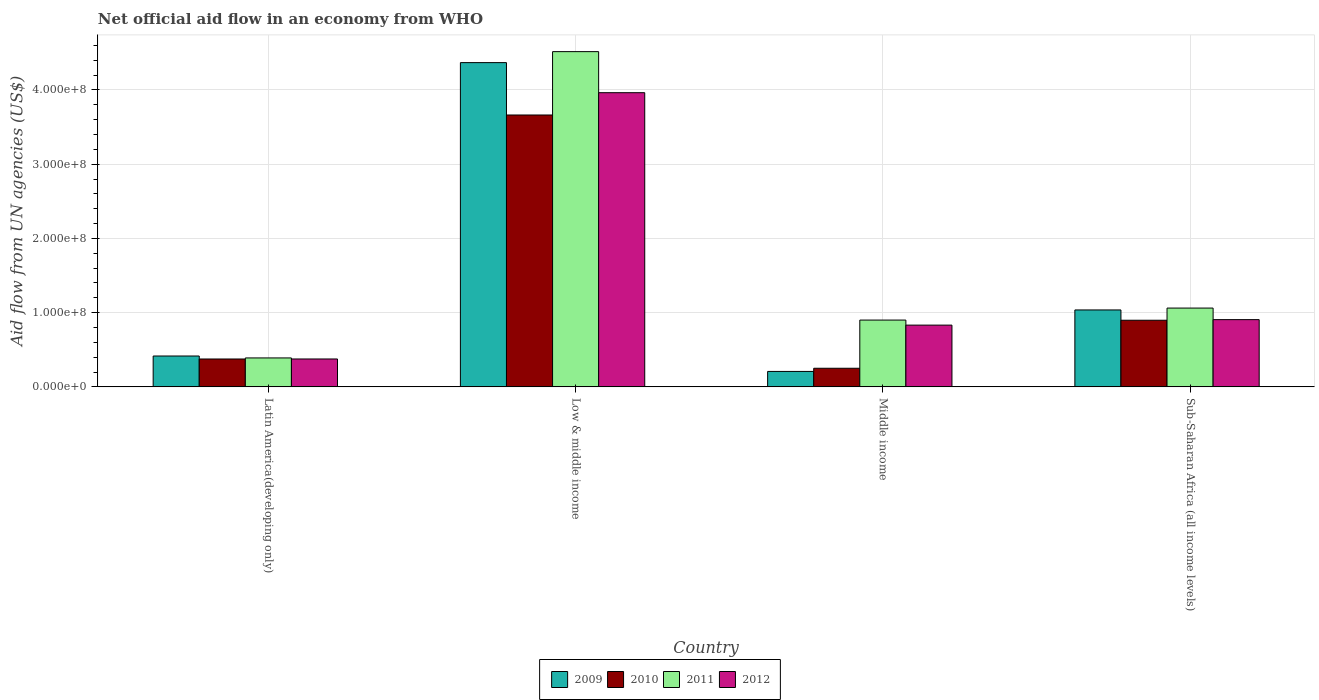How many different coloured bars are there?
Offer a very short reply. 4. How many bars are there on the 4th tick from the left?
Your answer should be very brief. 4. How many bars are there on the 4th tick from the right?
Offer a terse response. 4. What is the label of the 2nd group of bars from the left?
Offer a very short reply. Low & middle income. What is the net official aid flow in 2010 in Middle income?
Provide a succinct answer. 2.51e+07. Across all countries, what is the maximum net official aid flow in 2011?
Offer a very short reply. 4.52e+08. Across all countries, what is the minimum net official aid flow in 2010?
Provide a succinct answer. 2.51e+07. In which country was the net official aid flow in 2011 minimum?
Your answer should be very brief. Latin America(developing only). What is the total net official aid flow in 2009 in the graph?
Ensure brevity in your answer.  6.03e+08. What is the difference between the net official aid flow in 2011 in Latin America(developing only) and that in Sub-Saharan Africa (all income levels)?
Give a very brief answer. -6.72e+07. What is the difference between the net official aid flow in 2012 in Low & middle income and the net official aid flow in 2009 in Latin America(developing only)?
Provide a short and direct response. 3.55e+08. What is the average net official aid flow in 2009 per country?
Offer a very short reply. 1.51e+08. What is the difference between the net official aid flow of/in 2012 and net official aid flow of/in 2009 in Latin America(developing only)?
Offer a terse response. -3.99e+06. In how many countries, is the net official aid flow in 2010 greater than 220000000 US$?
Your answer should be very brief. 1. What is the ratio of the net official aid flow in 2010 in Low & middle income to that in Middle income?
Offer a very short reply. 14.61. What is the difference between the highest and the second highest net official aid flow in 2010?
Keep it short and to the point. 2.76e+08. What is the difference between the highest and the lowest net official aid flow in 2010?
Your answer should be compact. 3.41e+08. In how many countries, is the net official aid flow in 2011 greater than the average net official aid flow in 2011 taken over all countries?
Provide a succinct answer. 1. What does the 3rd bar from the left in Sub-Saharan Africa (all income levels) represents?
Provide a short and direct response. 2011. How many bars are there?
Your response must be concise. 16. What is the difference between two consecutive major ticks on the Y-axis?
Your answer should be compact. 1.00e+08. Does the graph contain grids?
Your answer should be very brief. Yes. What is the title of the graph?
Offer a terse response. Net official aid flow in an economy from WHO. Does "1982" appear as one of the legend labels in the graph?
Give a very brief answer. No. What is the label or title of the Y-axis?
Your answer should be compact. Aid flow from UN agencies (US$). What is the Aid flow from UN agencies (US$) of 2009 in Latin America(developing only)?
Keep it short and to the point. 4.16e+07. What is the Aid flow from UN agencies (US$) in 2010 in Latin America(developing only)?
Keep it short and to the point. 3.76e+07. What is the Aid flow from UN agencies (US$) in 2011 in Latin America(developing only)?
Offer a terse response. 3.90e+07. What is the Aid flow from UN agencies (US$) in 2012 in Latin America(developing only)?
Your answer should be very brief. 3.76e+07. What is the Aid flow from UN agencies (US$) in 2009 in Low & middle income?
Your answer should be compact. 4.37e+08. What is the Aid flow from UN agencies (US$) in 2010 in Low & middle income?
Provide a succinct answer. 3.66e+08. What is the Aid flow from UN agencies (US$) of 2011 in Low & middle income?
Keep it short and to the point. 4.52e+08. What is the Aid flow from UN agencies (US$) of 2012 in Low & middle income?
Offer a terse response. 3.96e+08. What is the Aid flow from UN agencies (US$) of 2009 in Middle income?
Provide a succinct answer. 2.08e+07. What is the Aid flow from UN agencies (US$) in 2010 in Middle income?
Offer a terse response. 2.51e+07. What is the Aid flow from UN agencies (US$) in 2011 in Middle income?
Your answer should be compact. 9.00e+07. What is the Aid flow from UN agencies (US$) of 2012 in Middle income?
Ensure brevity in your answer.  8.32e+07. What is the Aid flow from UN agencies (US$) in 2009 in Sub-Saharan Africa (all income levels)?
Ensure brevity in your answer.  1.04e+08. What is the Aid flow from UN agencies (US$) in 2010 in Sub-Saharan Africa (all income levels)?
Offer a terse response. 8.98e+07. What is the Aid flow from UN agencies (US$) of 2011 in Sub-Saharan Africa (all income levels)?
Provide a short and direct response. 1.06e+08. What is the Aid flow from UN agencies (US$) of 2012 in Sub-Saharan Africa (all income levels)?
Offer a very short reply. 9.06e+07. Across all countries, what is the maximum Aid flow from UN agencies (US$) in 2009?
Offer a terse response. 4.37e+08. Across all countries, what is the maximum Aid flow from UN agencies (US$) in 2010?
Your answer should be compact. 3.66e+08. Across all countries, what is the maximum Aid flow from UN agencies (US$) of 2011?
Offer a terse response. 4.52e+08. Across all countries, what is the maximum Aid flow from UN agencies (US$) in 2012?
Your answer should be very brief. 3.96e+08. Across all countries, what is the minimum Aid flow from UN agencies (US$) in 2009?
Keep it short and to the point. 2.08e+07. Across all countries, what is the minimum Aid flow from UN agencies (US$) of 2010?
Offer a very short reply. 2.51e+07. Across all countries, what is the minimum Aid flow from UN agencies (US$) in 2011?
Offer a terse response. 3.90e+07. Across all countries, what is the minimum Aid flow from UN agencies (US$) in 2012?
Ensure brevity in your answer.  3.76e+07. What is the total Aid flow from UN agencies (US$) in 2009 in the graph?
Offer a terse response. 6.03e+08. What is the total Aid flow from UN agencies (US$) in 2010 in the graph?
Your answer should be very brief. 5.19e+08. What is the total Aid flow from UN agencies (US$) in 2011 in the graph?
Make the answer very short. 6.87e+08. What is the total Aid flow from UN agencies (US$) in 2012 in the graph?
Offer a terse response. 6.08e+08. What is the difference between the Aid flow from UN agencies (US$) in 2009 in Latin America(developing only) and that in Low & middle income?
Offer a very short reply. -3.95e+08. What is the difference between the Aid flow from UN agencies (US$) of 2010 in Latin America(developing only) and that in Low & middle income?
Offer a terse response. -3.29e+08. What is the difference between the Aid flow from UN agencies (US$) of 2011 in Latin America(developing only) and that in Low & middle income?
Keep it short and to the point. -4.13e+08. What is the difference between the Aid flow from UN agencies (US$) of 2012 in Latin America(developing only) and that in Low & middle income?
Make the answer very short. -3.59e+08. What is the difference between the Aid flow from UN agencies (US$) in 2009 in Latin America(developing only) and that in Middle income?
Offer a very short reply. 2.08e+07. What is the difference between the Aid flow from UN agencies (US$) in 2010 in Latin America(developing only) and that in Middle income?
Provide a succinct answer. 1.25e+07. What is the difference between the Aid flow from UN agencies (US$) of 2011 in Latin America(developing only) and that in Middle income?
Make the answer very short. -5.10e+07. What is the difference between the Aid flow from UN agencies (US$) of 2012 in Latin America(developing only) and that in Middle income?
Make the answer very short. -4.56e+07. What is the difference between the Aid flow from UN agencies (US$) in 2009 in Latin America(developing only) and that in Sub-Saharan Africa (all income levels)?
Provide a short and direct response. -6.20e+07. What is the difference between the Aid flow from UN agencies (US$) in 2010 in Latin America(developing only) and that in Sub-Saharan Africa (all income levels)?
Give a very brief answer. -5.22e+07. What is the difference between the Aid flow from UN agencies (US$) of 2011 in Latin America(developing only) and that in Sub-Saharan Africa (all income levels)?
Your response must be concise. -6.72e+07. What is the difference between the Aid flow from UN agencies (US$) in 2012 in Latin America(developing only) and that in Sub-Saharan Africa (all income levels)?
Your response must be concise. -5.30e+07. What is the difference between the Aid flow from UN agencies (US$) in 2009 in Low & middle income and that in Middle income?
Ensure brevity in your answer.  4.16e+08. What is the difference between the Aid flow from UN agencies (US$) of 2010 in Low & middle income and that in Middle income?
Offer a terse response. 3.41e+08. What is the difference between the Aid flow from UN agencies (US$) of 2011 in Low & middle income and that in Middle income?
Keep it short and to the point. 3.62e+08. What is the difference between the Aid flow from UN agencies (US$) in 2012 in Low & middle income and that in Middle income?
Provide a succinct answer. 3.13e+08. What is the difference between the Aid flow from UN agencies (US$) in 2009 in Low & middle income and that in Sub-Saharan Africa (all income levels)?
Provide a short and direct response. 3.33e+08. What is the difference between the Aid flow from UN agencies (US$) of 2010 in Low & middle income and that in Sub-Saharan Africa (all income levels)?
Make the answer very short. 2.76e+08. What is the difference between the Aid flow from UN agencies (US$) in 2011 in Low & middle income and that in Sub-Saharan Africa (all income levels)?
Make the answer very short. 3.45e+08. What is the difference between the Aid flow from UN agencies (US$) of 2012 in Low & middle income and that in Sub-Saharan Africa (all income levels)?
Give a very brief answer. 3.06e+08. What is the difference between the Aid flow from UN agencies (US$) in 2009 in Middle income and that in Sub-Saharan Africa (all income levels)?
Your answer should be very brief. -8.28e+07. What is the difference between the Aid flow from UN agencies (US$) in 2010 in Middle income and that in Sub-Saharan Africa (all income levels)?
Make the answer very short. -6.47e+07. What is the difference between the Aid flow from UN agencies (US$) in 2011 in Middle income and that in Sub-Saharan Africa (all income levels)?
Give a very brief answer. -1.62e+07. What is the difference between the Aid flow from UN agencies (US$) of 2012 in Middle income and that in Sub-Saharan Africa (all income levels)?
Your answer should be very brief. -7.39e+06. What is the difference between the Aid flow from UN agencies (US$) in 2009 in Latin America(developing only) and the Aid flow from UN agencies (US$) in 2010 in Low & middle income?
Offer a terse response. -3.25e+08. What is the difference between the Aid flow from UN agencies (US$) in 2009 in Latin America(developing only) and the Aid flow from UN agencies (US$) in 2011 in Low & middle income?
Your response must be concise. -4.10e+08. What is the difference between the Aid flow from UN agencies (US$) of 2009 in Latin America(developing only) and the Aid flow from UN agencies (US$) of 2012 in Low & middle income?
Make the answer very short. -3.55e+08. What is the difference between the Aid flow from UN agencies (US$) of 2010 in Latin America(developing only) and the Aid flow from UN agencies (US$) of 2011 in Low & middle income?
Offer a terse response. -4.14e+08. What is the difference between the Aid flow from UN agencies (US$) of 2010 in Latin America(developing only) and the Aid flow from UN agencies (US$) of 2012 in Low & middle income?
Keep it short and to the point. -3.59e+08. What is the difference between the Aid flow from UN agencies (US$) in 2011 in Latin America(developing only) and the Aid flow from UN agencies (US$) in 2012 in Low & middle income?
Your response must be concise. -3.57e+08. What is the difference between the Aid flow from UN agencies (US$) in 2009 in Latin America(developing only) and the Aid flow from UN agencies (US$) in 2010 in Middle income?
Ensure brevity in your answer.  1.65e+07. What is the difference between the Aid flow from UN agencies (US$) of 2009 in Latin America(developing only) and the Aid flow from UN agencies (US$) of 2011 in Middle income?
Your answer should be compact. -4.84e+07. What is the difference between the Aid flow from UN agencies (US$) of 2009 in Latin America(developing only) and the Aid flow from UN agencies (US$) of 2012 in Middle income?
Your response must be concise. -4.16e+07. What is the difference between the Aid flow from UN agencies (US$) in 2010 in Latin America(developing only) and the Aid flow from UN agencies (US$) in 2011 in Middle income?
Provide a short and direct response. -5.24e+07. What is the difference between the Aid flow from UN agencies (US$) in 2010 in Latin America(developing only) and the Aid flow from UN agencies (US$) in 2012 in Middle income?
Provide a short and direct response. -4.56e+07. What is the difference between the Aid flow from UN agencies (US$) of 2011 in Latin America(developing only) and the Aid flow from UN agencies (US$) of 2012 in Middle income?
Give a very brief answer. -4.42e+07. What is the difference between the Aid flow from UN agencies (US$) in 2009 in Latin America(developing only) and the Aid flow from UN agencies (US$) in 2010 in Sub-Saharan Africa (all income levels)?
Your answer should be compact. -4.82e+07. What is the difference between the Aid flow from UN agencies (US$) in 2009 in Latin America(developing only) and the Aid flow from UN agencies (US$) in 2011 in Sub-Saharan Africa (all income levels)?
Ensure brevity in your answer.  -6.46e+07. What is the difference between the Aid flow from UN agencies (US$) of 2009 in Latin America(developing only) and the Aid flow from UN agencies (US$) of 2012 in Sub-Saharan Africa (all income levels)?
Offer a very short reply. -4.90e+07. What is the difference between the Aid flow from UN agencies (US$) in 2010 in Latin America(developing only) and the Aid flow from UN agencies (US$) in 2011 in Sub-Saharan Africa (all income levels)?
Make the answer very short. -6.86e+07. What is the difference between the Aid flow from UN agencies (US$) of 2010 in Latin America(developing only) and the Aid flow from UN agencies (US$) of 2012 in Sub-Saharan Africa (all income levels)?
Provide a succinct answer. -5.30e+07. What is the difference between the Aid flow from UN agencies (US$) in 2011 in Latin America(developing only) and the Aid flow from UN agencies (US$) in 2012 in Sub-Saharan Africa (all income levels)?
Make the answer very short. -5.16e+07. What is the difference between the Aid flow from UN agencies (US$) in 2009 in Low & middle income and the Aid flow from UN agencies (US$) in 2010 in Middle income?
Ensure brevity in your answer.  4.12e+08. What is the difference between the Aid flow from UN agencies (US$) in 2009 in Low & middle income and the Aid flow from UN agencies (US$) in 2011 in Middle income?
Offer a terse response. 3.47e+08. What is the difference between the Aid flow from UN agencies (US$) in 2009 in Low & middle income and the Aid flow from UN agencies (US$) in 2012 in Middle income?
Offer a very short reply. 3.54e+08. What is the difference between the Aid flow from UN agencies (US$) in 2010 in Low & middle income and the Aid flow from UN agencies (US$) in 2011 in Middle income?
Your answer should be compact. 2.76e+08. What is the difference between the Aid flow from UN agencies (US$) of 2010 in Low & middle income and the Aid flow from UN agencies (US$) of 2012 in Middle income?
Make the answer very short. 2.83e+08. What is the difference between the Aid flow from UN agencies (US$) of 2011 in Low & middle income and the Aid flow from UN agencies (US$) of 2012 in Middle income?
Provide a succinct answer. 3.68e+08. What is the difference between the Aid flow from UN agencies (US$) of 2009 in Low & middle income and the Aid flow from UN agencies (US$) of 2010 in Sub-Saharan Africa (all income levels)?
Your response must be concise. 3.47e+08. What is the difference between the Aid flow from UN agencies (US$) of 2009 in Low & middle income and the Aid flow from UN agencies (US$) of 2011 in Sub-Saharan Africa (all income levels)?
Provide a short and direct response. 3.31e+08. What is the difference between the Aid flow from UN agencies (US$) in 2009 in Low & middle income and the Aid flow from UN agencies (US$) in 2012 in Sub-Saharan Africa (all income levels)?
Your response must be concise. 3.46e+08. What is the difference between the Aid flow from UN agencies (US$) in 2010 in Low & middle income and the Aid flow from UN agencies (US$) in 2011 in Sub-Saharan Africa (all income levels)?
Give a very brief answer. 2.60e+08. What is the difference between the Aid flow from UN agencies (US$) of 2010 in Low & middle income and the Aid flow from UN agencies (US$) of 2012 in Sub-Saharan Africa (all income levels)?
Your answer should be very brief. 2.76e+08. What is the difference between the Aid flow from UN agencies (US$) in 2011 in Low & middle income and the Aid flow from UN agencies (US$) in 2012 in Sub-Saharan Africa (all income levels)?
Make the answer very short. 3.61e+08. What is the difference between the Aid flow from UN agencies (US$) of 2009 in Middle income and the Aid flow from UN agencies (US$) of 2010 in Sub-Saharan Africa (all income levels)?
Make the answer very short. -6.90e+07. What is the difference between the Aid flow from UN agencies (US$) in 2009 in Middle income and the Aid flow from UN agencies (US$) in 2011 in Sub-Saharan Africa (all income levels)?
Offer a very short reply. -8.54e+07. What is the difference between the Aid flow from UN agencies (US$) of 2009 in Middle income and the Aid flow from UN agencies (US$) of 2012 in Sub-Saharan Africa (all income levels)?
Your answer should be compact. -6.98e+07. What is the difference between the Aid flow from UN agencies (US$) of 2010 in Middle income and the Aid flow from UN agencies (US$) of 2011 in Sub-Saharan Africa (all income levels)?
Keep it short and to the point. -8.11e+07. What is the difference between the Aid flow from UN agencies (US$) in 2010 in Middle income and the Aid flow from UN agencies (US$) in 2012 in Sub-Saharan Africa (all income levels)?
Ensure brevity in your answer.  -6.55e+07. What is the difference between the Aid flow from UN agencies (US$) in 2011 in Middle income and the Aid flow from UN agencies (US$) in 2012 in Sub-Saharan Africa (all income levels)?
Your answer should be compact. -5.90e+05. What is the average Aid flow from UN agencies (US$) in 2009 per country?
Provide a short and direct response. 1.51e+08. What is the average Aid flow from UN agencies (US$) in 2010 per country?
Offer a very short reply. 1.30e+08. What is the average Aid flow from UN agencies (US$) of 2011 per country?
Your answer should be compact. 1.72e+08. What is the average Aid flow from UN agencies (US$) of 2012 per country?
Offer a very short reply. 1.52e+08. What is the difference between the Aid flow from UN agencies (US$) of 2009 and Aid flow from UN agencies (US$) of 2010 in Latin America(developing only)?
Make the answer very short. 4.01e+06. What is the difference between the Aid flow from UN agencies (US$) of 2009 and Aid flow from UN agencies (US$) of 2011 in Latin America(developing only)?
Offer a very short reply. 2.59e+06. What is the difference between the Aid flow from UN agencies (US$) in 2009 and Aid flow from UN agencies (US$) in 2012 in Latin America(developing only)?
Your response must be concise. 3.99e+06. What is the difference between the Aid flow from UN agencies (US$) of 2010 and Aid flow from UN agencies (US$) of 2011 in Latin America(developing only)?
Provide a short and direct response. -1.42e+06. What is the difference between the Aid flow from UN agencies (US$) in 2011 and Aid flow from UN agencies (US$) in 2012 in Latin America(developing only)?
Make the answer very short. 1.40e+06. What is the difference between the Aid flow from UN agencies (US$) in 2009 and Aid flow from UN agencies (US$) in 2010 in Low & middle income?
Keep it short and to the point. 7.06e+07. What is the difference between the Aid flow from UN agencies (US$) of 2009 and Aid flow from UN agencies (US$) of 2011 in Low & middle income?
Keep it short and to the point. -1.48e+07. What is the difference between the Aid flow from UN agencies (US$) of 2009 and Aid flow from UN agencies (US$) of 2012 in Low & middle income?
Your answer should be very brief. 4.05e+07. What is the difference between the Aid flow from UN agencies (US$) of 2010 and Aid flow from UN agencies (US$) of 2011 in Low & middle income?
Provide a short and direct response. -8.54e+07. What is the difference between the Aid flow from UN agencies (US$) of 2010 and Aid flow from UN agencies (US$) of 2012 in Low & middle income?
Keep it short and to the point. -3.00e+07. What is the difference between the Aid flow from UN agencies (US$) in 2011 and Aid flow from UN agencies (US$) in 2012 in Low & middle income?
Your answer should be very brief. 5.53e+07. What is the difference between the Aid flow from UN agencies (US$) of 2009 and Aid flow from UN agencies (US$) of 2010 in Middle income?
Give a very brief answer. -4.27e+06. What is the difference between the Aid flow from UN agencies (US$) in 2009 and Aid flow from UN agencies (US$) in 2011 in Middle income?
Ensure brevity in your answer.  -6.92e+07. What is the difference between the Aid flow from UN agencies (US$) of 2009 and Aid flow from UN agencies (US$) of 2012 in Middle income?
Offer a terse response. -6.24e+07. What is the difference between the Aid flow from UN agencies (US$) of 2010 and Aid flow from UN agencies (US$) of 2011 in Middle income?
Your answer should be very brief. -6.49e+07. What is the difference between the Aid flow from UN agencies (US$) of 2010 and Aid flow from UN agencies (US$) of 2012 in Middle income?
Your answer should be compact. -5.81e+07. What is the difference between the Aid flow from UN agencies (US$) of 2011 and Aid flow from UN agencies (US$) of 2012 in Middle income?
Provide a succinct answer. 6.80e+06. What is the difference between the Aid flow from UN agencies (US$) in 2009 and Aid flow from UN agencies (US$) in 2010 in Sub-Saharan Africa (all income levels)?
Ensure brevity in your answer.  1.39e+07. What is the difference between the Aid flow from UN agencies (US$) in 2009 and Aid flow from UN agencies (US$) in 2011 in Sub-Saharan Africa (all income levels)?
Your answer should be very brief. -2.53e+06. What is the difference between the Aid flow from UN agencies (US$) of 2009 and Aid flow from UN agencies (US$) of 2012 in Sub-Saharan Africa (all income levels)?
Your response must be concise. 1.30e+07. What is the difference between the Aid flow from UN agencies (US$) in 2010 and Aid flow from UN agencies (US$) in 2011 in Sub-Saharan Africa (all income levels)?
Your answer should be very brief. -1.64e+07. What is the difference between the Aid flow from UN agencies (US$) of 2010 and Aid flow from UN agencies (US$) of 2012 in Sub-Saharan Africa (all income levels)?
Provide a short and direct response. -8.10e+05. What is the difference between the Aid flow from UN agencies (US$) of 2011 and Aid flow from UN agencies (US$) of 2012 in Sub-Saharan Africa (all income levels)?
Make the answer very short. 1.56e+07. What is the ratio of the Aid flow from UN agencies (US$) in 2009 in Latin America(developing only) to that in Low & middle income?
Keep it short and to the point. 0.1. What is the ratio of the Aid flow from UN agencies (US$) in 2010 in Latin America(developing only) to that in Low & middle income?
Make the answer very short. 0.1. What is the ratio of the Aid flow from UN agencies (US$) in 2011 in Latin America(developing only) to that in Low & middle income?
Provide a succinct answer. 0.09. What is the ratio of the Aid flow from UN agencies (US$) of 2012 in Latin America(developing only) to that in Low & middle income?
Provide a short and direct response. 0.09. What is the ratio of the Aid flow from UN agencies (US$) in 2009 in Latin America(developing only) to that in Middle income?
Offer a terse response. 2. What is the ratio of the Aid flow from UN agencies (US$) in 2010 in Latin America(developing only) to that in Middle income?
Provide a short and direct response. 1.5. What is the ratio of the Aid flow from UN agencies (US$) of 2011 in Latin America(developing only) to that in Middle income?
Make the answer very short. 0.43. What is the ratio of the Aid flow from UN agencies (US$) of 2012 in Latin America(developing only) to that in Middle income?
Your answer should be compact. 0.45. What is the ratio of the Aid flow from UN agencies (US$) in 2009 in Latin America(developing only) to that in Sub-Saharan Africa (all income levels)?
Keep it short and to the point. 0.4. What is the ratio of the Aid flow from UN agencies (US$) in 2010 in Latin America(developing only) to that in Sub-Saharan Africa (all income levels)?
Give a very brief answer. 0.42. What is the ratio of the Aid flow from UN agencies (US$) of 2011 in Latin America(developing only) to that in Sub-Saharan Africa (all income levels)?
Give a very brief answer. 0.37. What is the ratio of the Aid flow from UN agencies (US$) in 2012 in Latin America(developing only) to that in Sub-Saharan Africa (all income levels)?
Offer a terse response. 0.41. What is the ratio of the Aid flow from UN agencies (US$) in 2009 in Low & middle income to that in Middle income?
Offer a very short reply. 21. What is the ratio of the Aid flow from UN agencies (US$) of 2010 in Low & middle income to that in Middle income?
Your answer should be compact. 14.61. What is the ratio of the Aid flow from UN agencies (US$) of 2011 in Low & middle income to that in Middle income?
Offer a very short reply. 5.02. What is the ratio of the Aid flow from UN agencies (US$) of 2012 in Low & middle income to that in Middle income?
Your response must be concise. 4.76. What is the ratio of the Aid flow from UN agencies (US$) in 2009 in Low & middle income to that in Sub-Saharan Africa (all income levels)?
Offer a very short reply. 4.22. What is the ratio of the Aid flow from UN agencies (US$) in 2010 in Low & middle income to that in Sub-Saharan Africa (all income levels)?
Your response must be concise. 4.08. What is the ratio of the Aid flow from UN agencies (US$) in 2011 in Low & middle income to that in Sub-Saharan Africa (all income levels)?
Your answer should be very brief. 4.25. What is the ratio of the Aid flow from UN agencies (US$) of 2012 in Low & middle income to that in Sub-Saharan Africa (all income levels)?
Your answer should be compact. 4.38. What is the ratio of the Aid flow from UN agencies (US$) in 2009 in Middle income to that in Sub-Saharan Africa (all income levels)?
Your answer should be very brief. 0.2. What is the ratio of the Aid flow from UN agencies (US$) in 2010 in Middle income to that in Sub-Saharan Africa (all income levels)?
Provide a short and direct response. 0.28. What is the ratio of the Aid flow from UN agencies (US$) in 2011 in Middle income to that in Sub-Saharan Africa (all income levels)?
Ensure brevity in your answer.  0.85. What is the ratio of the Aid flow from UN agencies (US$) in 2012 in Middle income to that in Sub-Saharan Africa (all income levels)?
Offer a very short reply. 0.92. What is the difference between the highest and the second highest Aid flow from UN agencies (US$) of 2009?
Make the answer very short. 3.33e+08. What is the difference between the highest and the second highest Aid flow from UN agencies (US$) in 2010?
Your answer should be very brief. 2.76e+08. What is the difference between the highest and the second highest Aid flow from UN agencies (US$) in 2011?
Provide a succinct answer. 3.45e+08. What is the difference between the highest and the second highest Aid flow from UN agencies (US$) in 2012?
Offer a terse response. 3.06e+08. What is the difference between the highest and the lowest Aid flow from UN agencies (US$) in 2009?
Offer a very short reply. 4.16e+08. What is the difference between the highest and the lowest Aid flow from UN agencies (US$) of 2010?
Ensure brevity in your answer.  3.41e+08. What is the difference between the highest and the lowest Aid flow from UN agencies (US$) in 2011?
Provide a short and direct response. 4.13e+08. What is the difference between the highest and the lowest Aid flow from UN agencies (US$) in 2012?
Your answer should be very brief. 3.59e+08. 